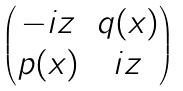<formula> <loc_0><loc_0><loc_500><loc_500>\begin{pmatrix} - i z & q ( x ) \\ p ( x ) & i z \end{pmatrix}</formula> 